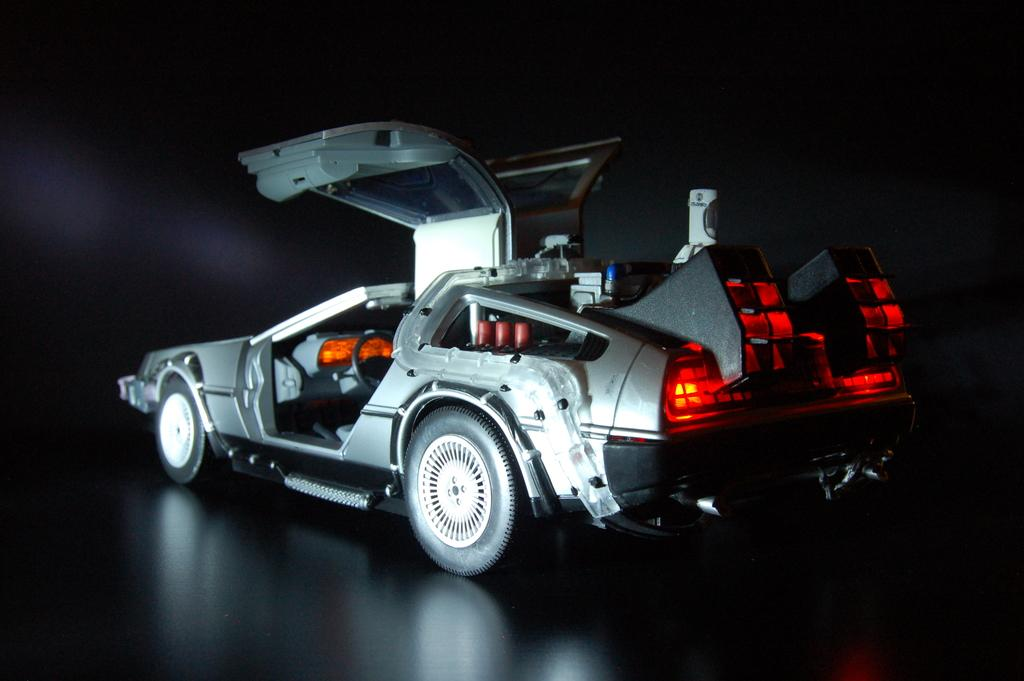What is the main subject of the image? The main subject of the image is a car. Can you describe the background of the image? The background of the image is dark. What type of power does the car's dad generate in the image? There is no mention of a car's dad or any power generation in the image. Can you see a coil in the image? There is no coil present in the image. 